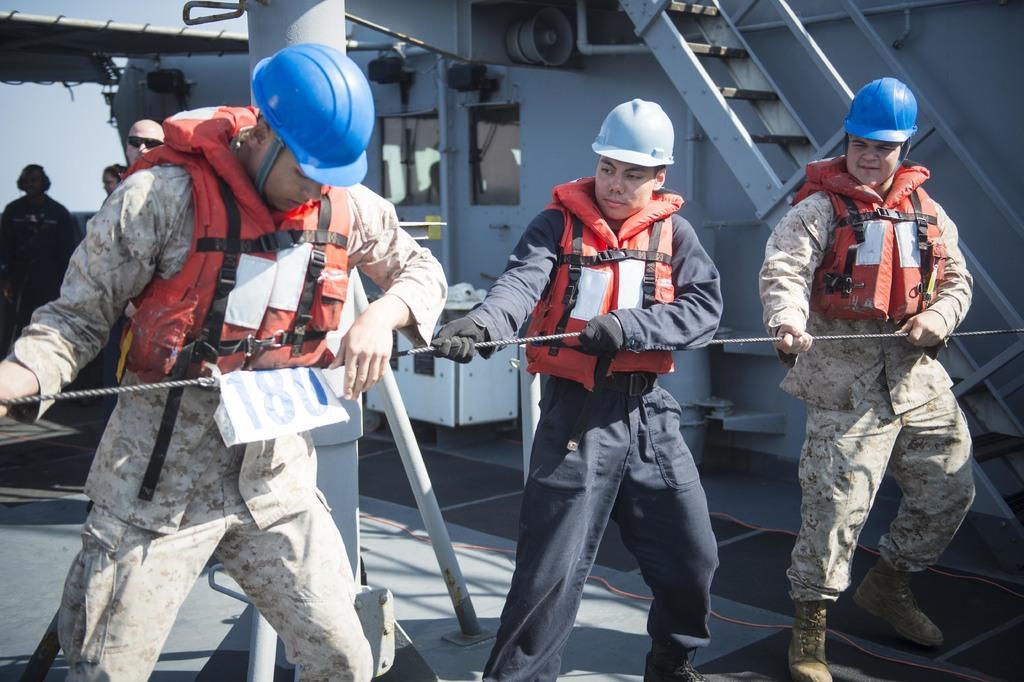Could you give a brief overview of what you see in this image? In this image there are three workers who are standing one beside the other are pulling the rope. Behind them there are steps. On the left side there are few people standing on the floor behind them. 